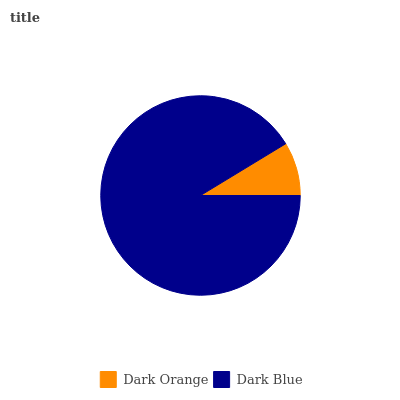Is Dark Orange the minimum?
Answer yes or no. Yes. Is Dark Blue the maximum?
Answer yes or no. Yes. Is Dark Blue the minimum?
Answer yes or no. No. Is Dark Blue greater than Dark Orange?
Answer yes or no. Yes. Is Dark Orange less than Dark Blue?
Answer yes or no. Yes. Is Dark Orange greater than Dark Blue?
Answer yes or no. No. Is Dark Blue less than Dark Orange?
Answer yes or no. No. Is Dark Blue the high median?
Answer yes or no. Yes. Is Dark Orange the low median?
Answer yes or no. Yes. Is Dark Orange the high median?
Answer yes or no. No. Is Dark Blue the low median?
Answer yes or no. No. 